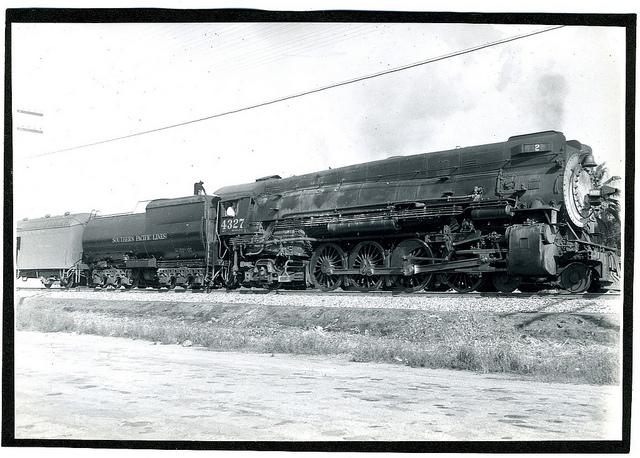Is there smoke coming out the train?
Write a very short answer. Yes. What color is the photo?
Be succinct. Black and white. Is this a color photograph?
Give a very brief answer. No. 